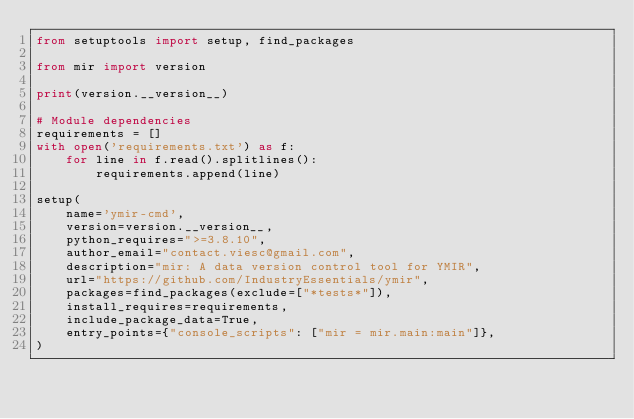Convert code to text. <code><loc_0><loc_0><loc_500><loc_500><_Python_>from setuptools import setup, find_packages

from mir import version

print(version.__version__)

# Module dependencies
requirements = []
with open('requirements.txt') as f:
    for line in f.read().splitlines():
        requirements.append(line)

setup(
    name='ymir-cmd',
    version=version.__version__,
    python_requires=">=3.8.10",
    author_email="contact.viesc@gmail.com",
    description="mir: A data version control tool for YMIR",
    url="https://github.com/IndustryEssentials/ymir",
    packages=find_packages(exclude=["*tests*"]),
    install_requires=requirements,
    include_package_data=True,
    entry_points={"console_scripts": ["mir = mir.main:main"]},
)
</code> 